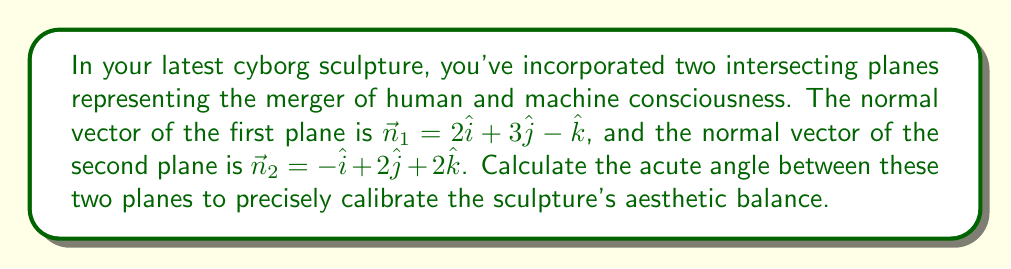Give your solution to this math problem. To find the angle between two intersecting planes, we can use the angle between their normal vectors. The formula for the angle $\theta$ between two vectors $\vec{a}$ and $\vec{b}$ is:

$$\cos\theta = \frac{\vec{a} \cdot \vec{b}}{|\vec{a}||\vec{b}|}$$

Step 1: Calculate the dot product of the normal vectors.
$$\vec{n}_1 \cdot \vec{n}_2 = (2)(-1) + (3)(2) + (-1)(2) = -2 + 6 - 2 = 2$$

Step 2: Calculate the magnitudes of the normal vectors.
$$|\vec{n}_1| = \sqrt{2^2 + 3^2 + (-1)^2} = \sqrt{4 + 9 + 1} = \sqrt{14}$$
$$|\vec{n}_2| = \sqrt{(-1)^2 + 2^2 + 2^2} = \sqrt{1 + 4 + 4} = 3$$

Step 3: Substitute into the formula.
$$\cos\theta = \frac{2}{\sqrt{14} \cdot 3}$$

Step 4: Simplify.
$$\cos\theta = \frac{2}{3\sqrt{14}}$$

Step 5: Take the inverse cosine (arccos) of both sides.
$$\theta = \arccos\left(\frac{2}{3\sqrt{14}}\right)$$

Step 6: Convert to degrees.
$$\theta \approx 75.52°$$
Answer: $75.52°$ 